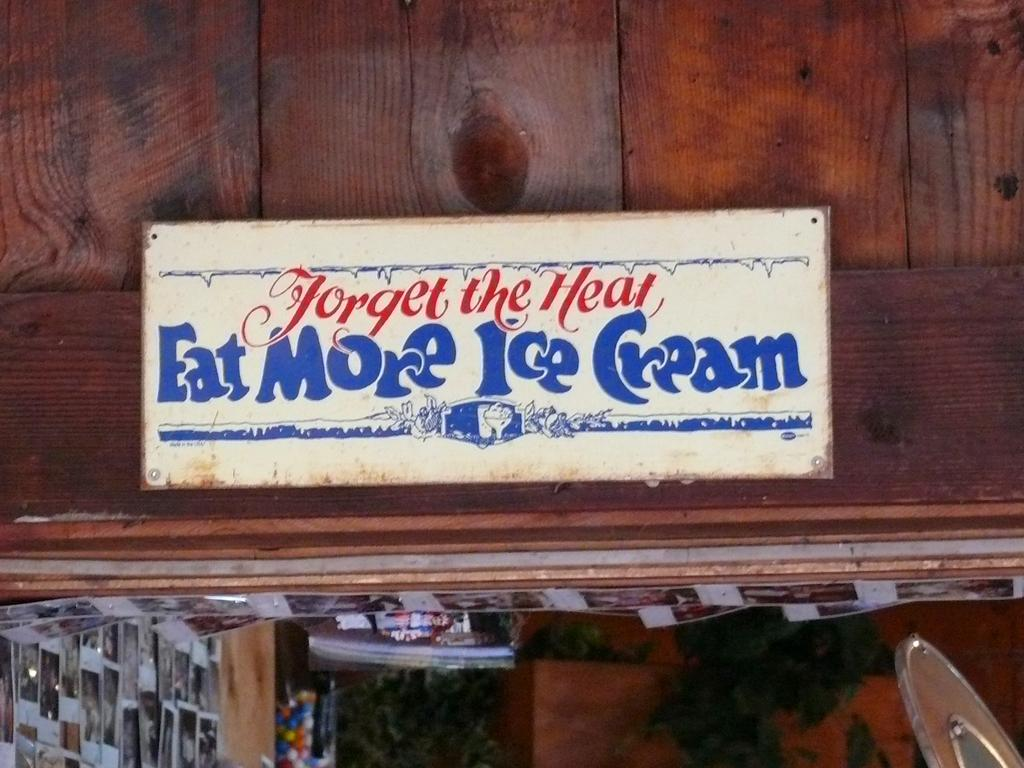What is the main subject of the image? The main subject of the image is many photos. Can you describe the background of the image? There is a board attached to a brown color wall in the background. What is written or displayed on the board? Something is written on the board. How many lakes can be seen in the image? There are no lakes present in the image; it features photos and a board on a brown wall. What type of money is depicted in the image? There is no money depicted in the image. 